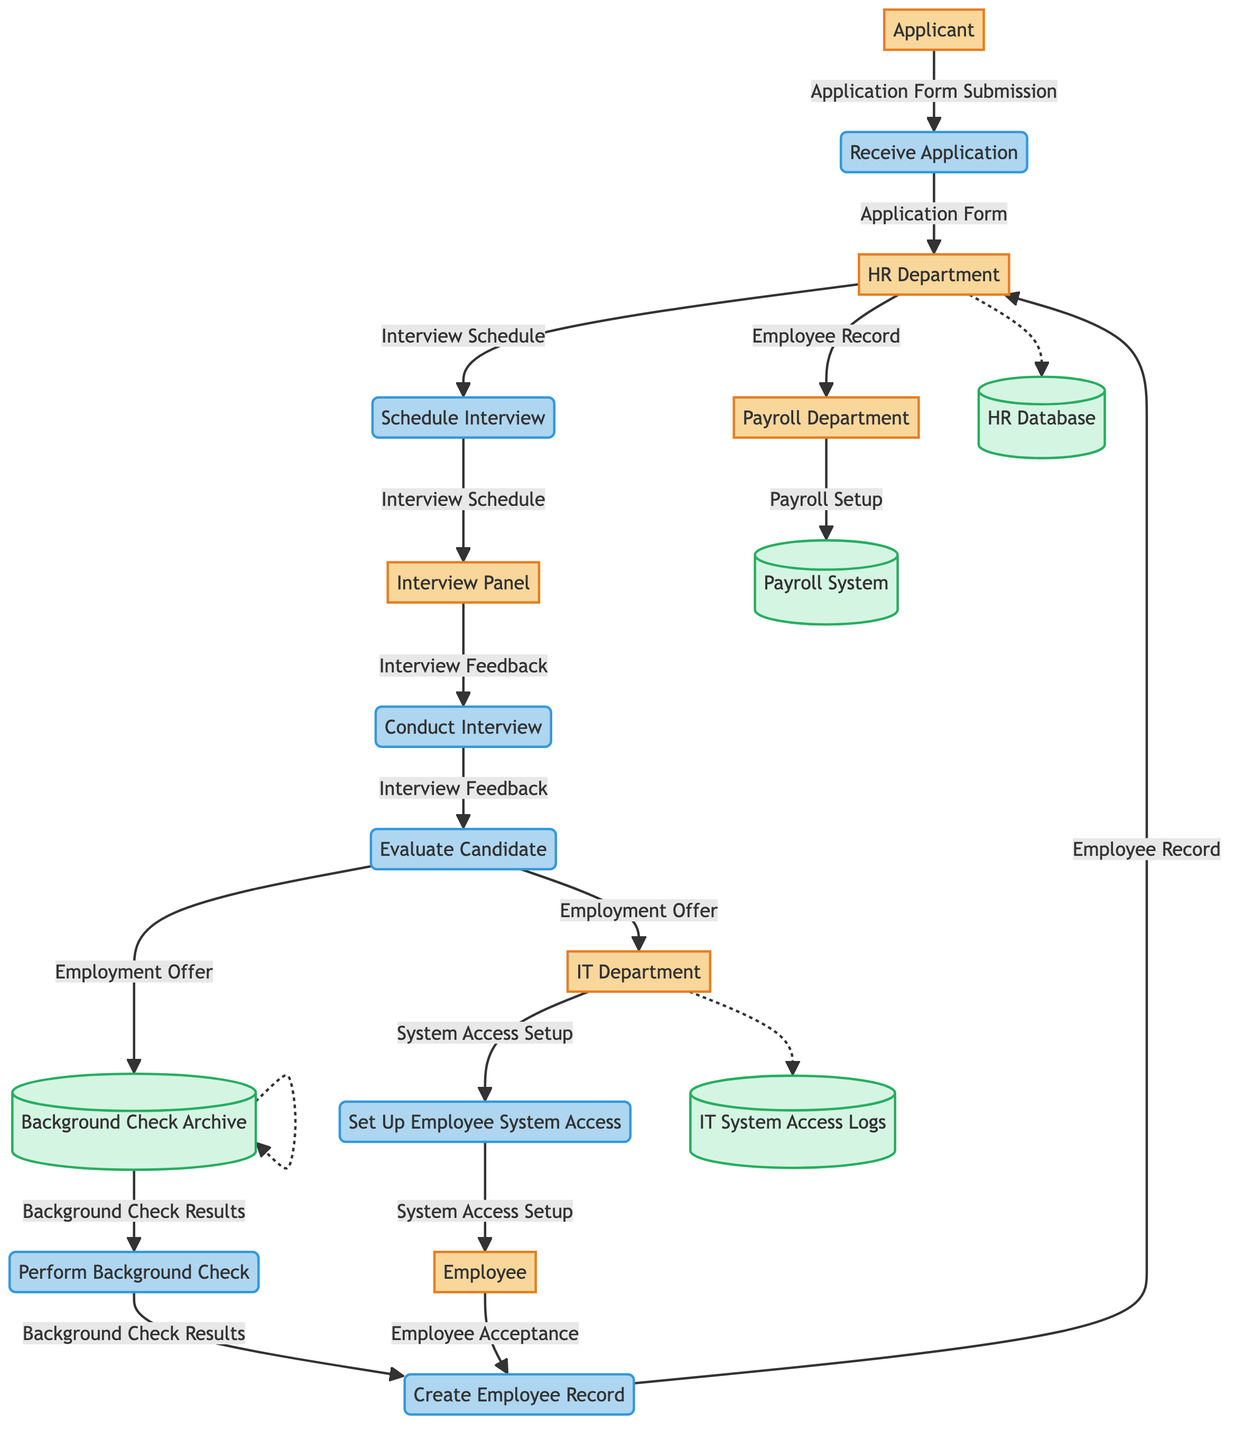What is the initial input for the application process? The initial input is "Application Form Submission" provided by the "Applicant." This is the starting point of the onboarding process.
Answer: Application Form Submission How many entities are involved in the employee onboarding process? The diagram lists six distinct entities: Applicant, HR Department, Interview Panel, Background Check Agency, IT Department, Payroll Department, and Employee. Adding them gives a total of six entities.
Answer: Six What output is generated after the "Evaluate Candidate" process? The output generated after the "Evaluate Candidate" process is the "Employment Offer." This is produced by processing the "Interview Feedback."
Answer: Employment Offer Which department receives the "Interview Schedule"? The "HR Department" receives the "Interview Schedule" as output from the "Schedule Interview" process, indicating they coordinate the interview times.
Answer: HR Department What is stored in the HR Database? The HR Database stores inputs such as the "Application Form," "Interview Feedback," and "Employee Record," which are crucial for maintaining employee information.
Answer: Employee Information What process follows receiving the background check results? After receiving the background check results, the next process is "Create Employee Record." This step combines the employment offer, background check results, and employee acceptance to create the official record.
Answer: Create Employee Record Where does "System Access Setup" output go after being created? After "System Access Setup" is generated, it is sent to the "Employee," who uses it to manage their official system access. This facilitates their onboarding process.
Answer: Employee How is the "Payroll Setup" created? The "Payroll Setup" is created by the "Payroll Department" upon receiving the "Employee Record." This links payroll processing directly to the created employee data.
Answer: Payroll Setup What is the role of the Background Check Agency? The Background Check Agency is responsible for performing the background check, where it receives the "Employment Offer" to assess the applicant’s history and delivers the "Background Check Results."
Answer: Perform Background Check 